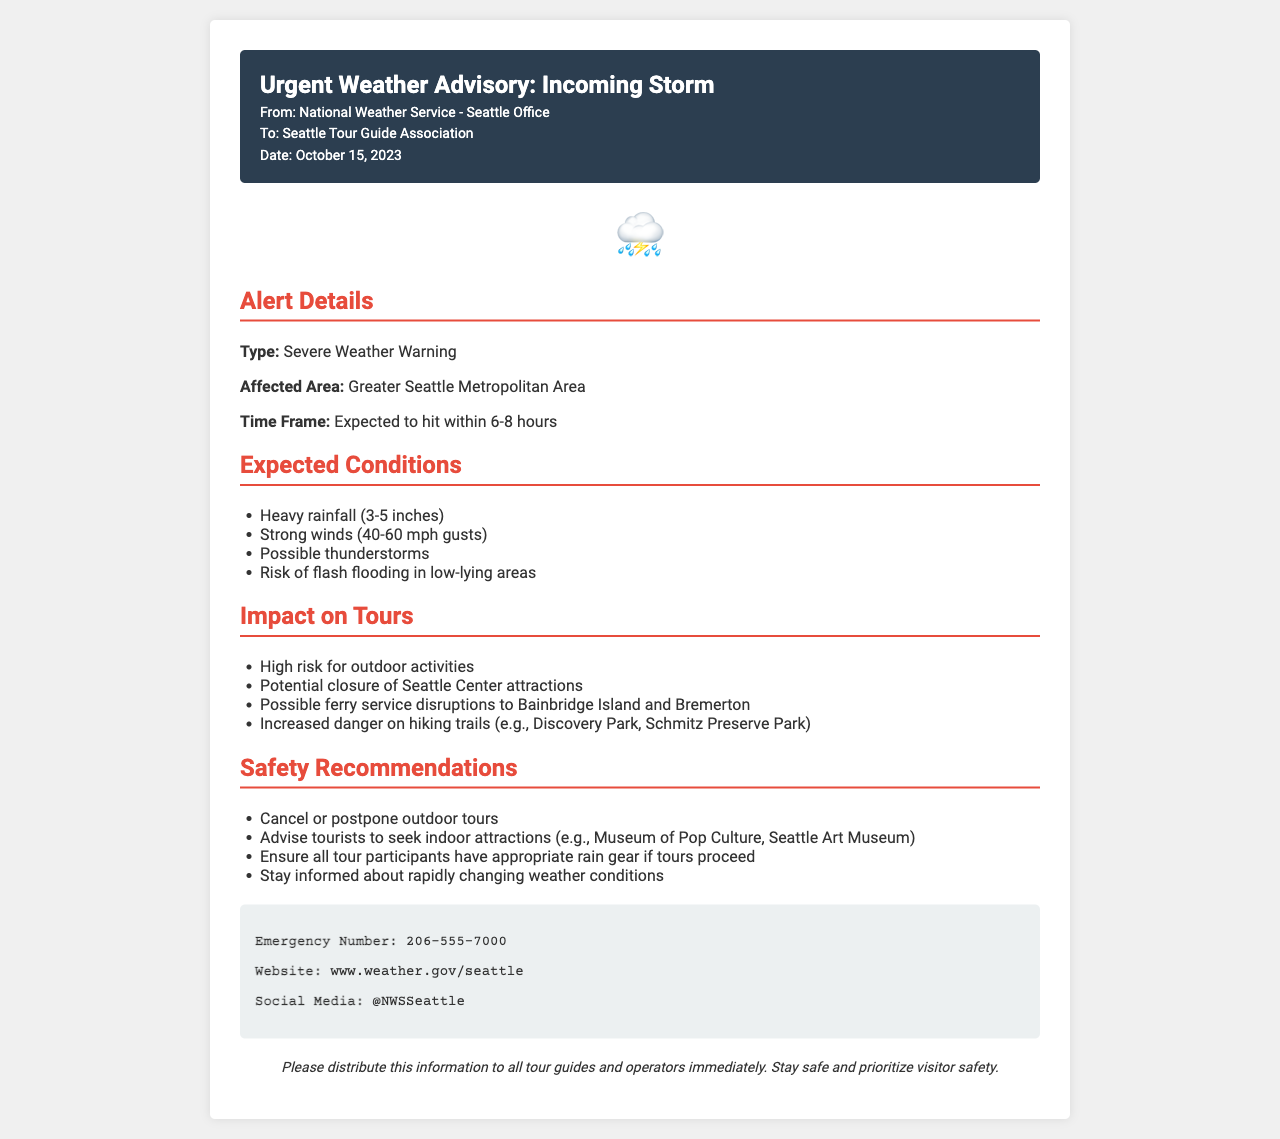What is the type of weather warning issued? The document states that the type of warning is a "Severe Weather Warning."
Answer: Severe Weather Warning What is the expected time frame for the storm to hit? The document specifies that the storm is expected to hit within "6-8 hours."
Answer: 6-8 hours What are the expected wind gusts? The document mentions that wind gusts are expected to be "40-60 mph."
Answer: 40-60 mph What is one of the recommended safety measures? The document advises to "cancel or postpone outdoor tours."
Answer: Cancel or postpone outdoor tours What area is affected by the storm? The document identifies the affected area as the "Greater Seattle Metropolitan Area."
Answer: Greater Seattle Metropolitan Area What is the emergency contact number provided? The document includes an emergency number, which is "206-555-7000."
Answer: 206-555-7000 What is the potential impact on ferry service? The document indicates that there may be "possible ferry service disruptions."
Answer: Possible ferry service disruptions Which indoor attractions should tourists consider? The document recommends tourists to seek "Museum of Pop Culture" as an indoor attraction.
Answer: Museum of Pop Culture What is the date of the advisory? The document states that the advisory was issued on "October 15, 2023."
Answer: October 15, 2023 